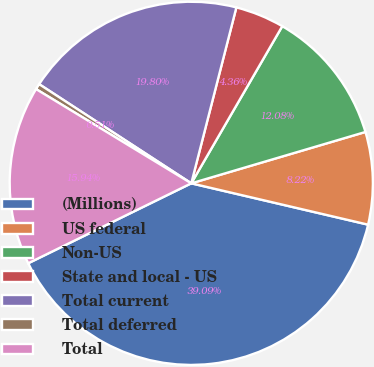Convert chart to OTSL. <chart><loc_0><loc_0><loc_500><loc_500><pie_chart><fcel>(Millions)<fcel>US federal<fcel>Non-US<fcel>State and local - US<fcel>Total current<fcel>Total deferred<fcel>Total<nl><fcel>39.09%<fcel>8.22%<fcel>12.08%<fcel>4.36%<fcel>19.8%<fcel>0.51%<fcel>15.94%<nl></chart> 